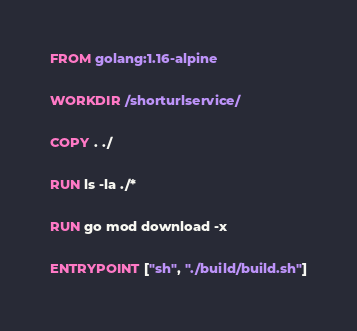Convert code to text. <code><loc_0><loc_0><loc_500><loc_500><_Dockerfile_>FROM golang:1.16-alpine

WORKDIR /shorturlservice/

COPY . ./

RUN ls -la ./*

RUN go mod download -x

ENTRYPOINT ["sh", "./build/build.sh"]</code> 